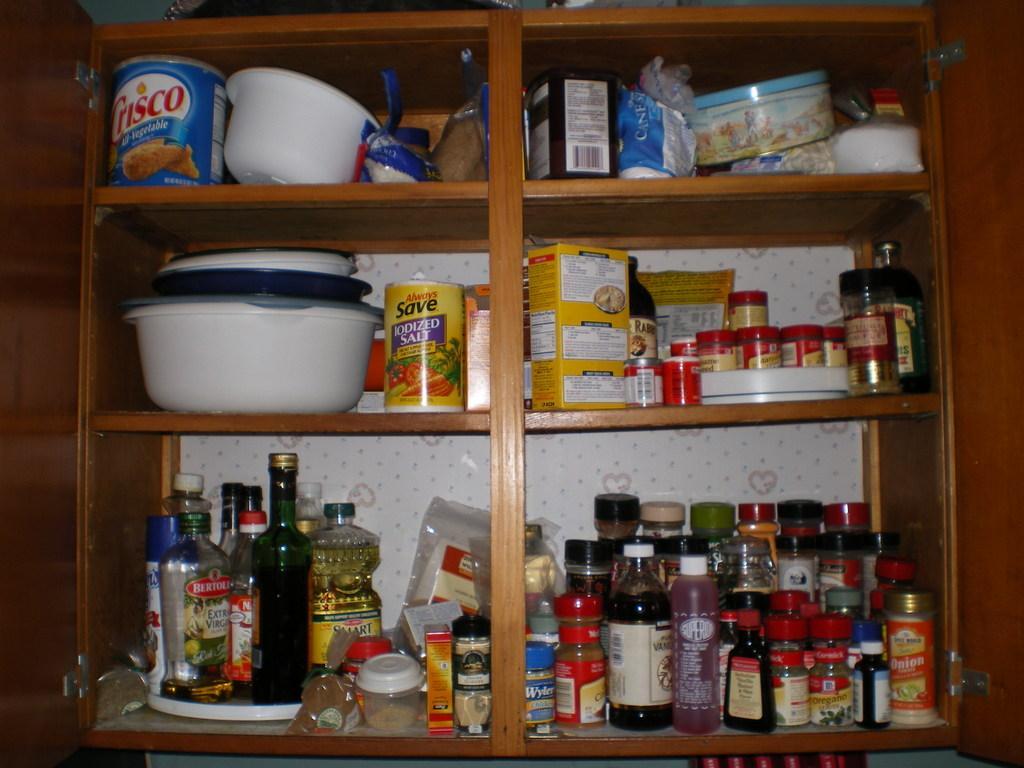Could you give a brief overview of what you see in this image? In this image I can see an open shelf with racks. In the racks on the shelf there are bottles, containers, food packets, food boxes and some other objects. 